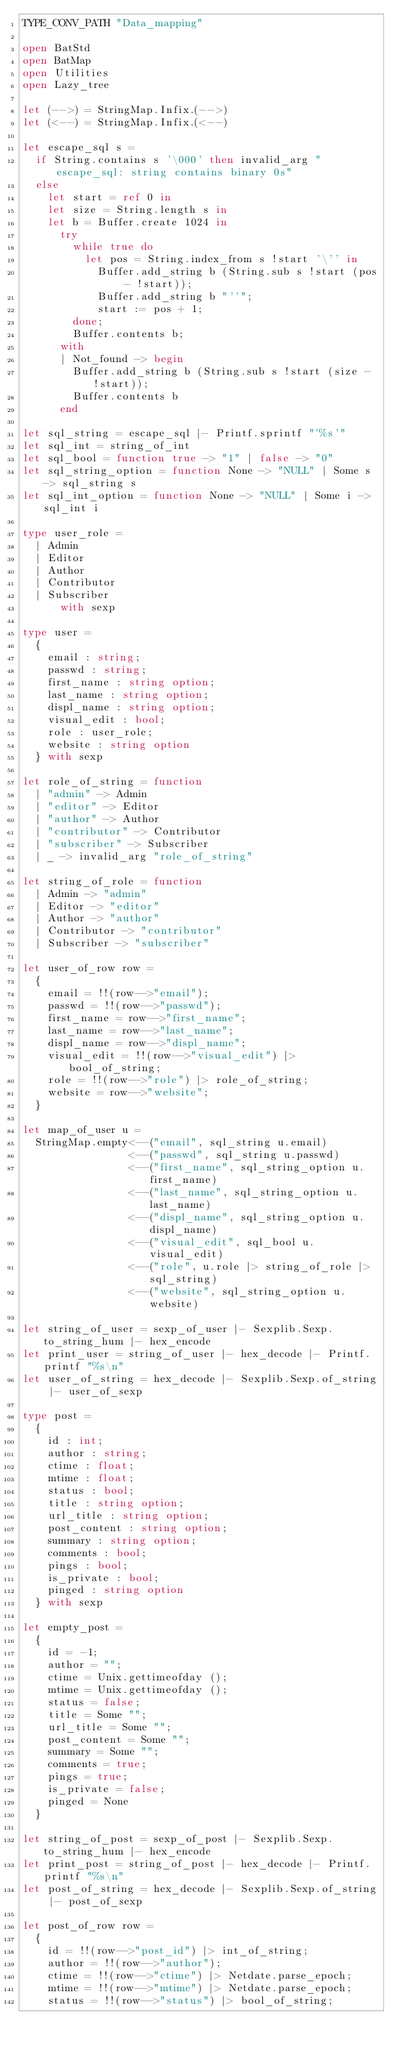<code> <loc_0><loc_0><loc_500><loc_500><_OCaml_>TYPE_CONV_PATH "Data_mapping"

open BatStd
open BatMap
open Utilities
open Lazy_tree

let (-->) = StringMap.Infix.(-->)
let (<--) = StringMap.Infix.(<--)

let escape_sql s =
  if String.contains s '\000' then invalid_arg "escape_sql: string contains binary 0s"
  else
    let start = ref 0 in
    let size = String.length s in
    let b = Buffer.create 1024 in
      try
        while true do
          let pos = String.index_from s !start '\'' in
            Buffer.add_string b (String.sub s !start (pos - !start));
            Buffer.add_string b "''";
            start := pos + 1;
        done;
        Buffer.contents b;
      with
      | Not_found -> begin
        Buffer.add_string b (String.sub s !start (size - !start));
        Buffer.contents b
      end

let sql_string = escape_sql |- Printf.sprintf "'%s'"
let sql_int = string_of_int
let sql_bool = function true -> "1" | false -> "0"
let sql_string_option = function None -> "NULL" | Some s -> sql_string s
let sql_int_option = function None -> "NULL" | Some i -> sql_int i

type user_role =
  | Admin
  | Editor
  | Author
  | Contributor
  | Subscriber
      with sexp

type user =
  {
    email : string;
    passwd : string;
    first_name : string option;
    last_name : string option;
    displ_name : string option;
    visual_edit : bool;
    role : user_role;
    website : string option
  } with sexp

let role_of_string = function
  | "admin" -> Admin
  | "editor" -> Editor
  | "author" -> Author
  | "contributor" -> Contributor
  | "subscriber" -> Subscriber
  | _ -> invalid_arg "role_of_string"

let string_of_role = function
  | Admin -> "admin"
  | Editor -> "editor"
  | Author -> "author"
  | Contributor -> "contributor"
  | Subscriber -> "subscriber"

let user_of_row row =
  {
    email = !!(row-->"email");
    passwd = !!(row-->"passwd");
    first_name = row-->"first_name";
    last_name = row-->"last_name";
    displ_name = row-->"displ_name";
    visual_edit = !!(row-->"visual_edit") |> bool_of_string;
    role = !!(row-->"role") |> role_of_string;
    website = row-->"website";
  }

let map_of_user u =
  StringMap.empty<--("email", sql_string u.email)
                 <--("passwd", sql_string u.passwd)
                 <--("first_name", sql_string_option u.first_name)
                 <--("last_name", sql_string_option u.last_name)
                 <--("displ_name", sql_string_option u.displ_name)
                 <--("visual_edit", sql_bool u.visual_edit)
                 <--("role", u.role |> string_of_role |> sql_string)
                 <--("website", sql_string_option u.website)

let string_of_user = sexp_of_user |- Sexplib.Sexp.to_string_hum |- hex_encode
let print_user = string_of_user |- hex_decode |- Printf.printf "%s\n"
let user_of_string = hex_decode |- Sexplib.Sexp.of_string |- user_of_sexp

type post =
  {
    id : int;
    author : string;
    ctime : float;
    mtime : float;
    status : bool;
    title : string option;
    url_title : string option;
    post_content : string option;
    summary : string option;
    comments : bool;
    pings : bool;
    is_private : bool;
    pinged : string option
  } with sexp

let empty_post =
  {
    id = -1;
    author = "";
    ctime = Unix.gettimeofday ();
    mtime = Unix.gettimeofday ();
    status = false;
    title = Some "";
    url_title = Some "";
    post_content = Some "";
    summary = Some "";
    comments = true;
    pings = true;
    is_private = false;
    pinged = None
  }

let string_of_post = sexp_of_post |- Sexplib.Sexp.to_string_hum |- hex_encode
let print_post = string_of_post |- hex_decode |- Printf.printf "%s\n"
let post_of_string = hex_decode |- Sexplib.Sexp.of_string |- post_of_sexp

let post_of_row row =
  {
    id = !!(row-->"post_id") |> int_of_string;
    author = !!(row-->"author");
    ctime = !!(row-->"ctime") |> Netdate.parse_epoch;
    mtime = !!(row-->"mtime") |> Netdate.parse_epoch;
    status = !!(row-->"status") |> bool_of_string;</code> 